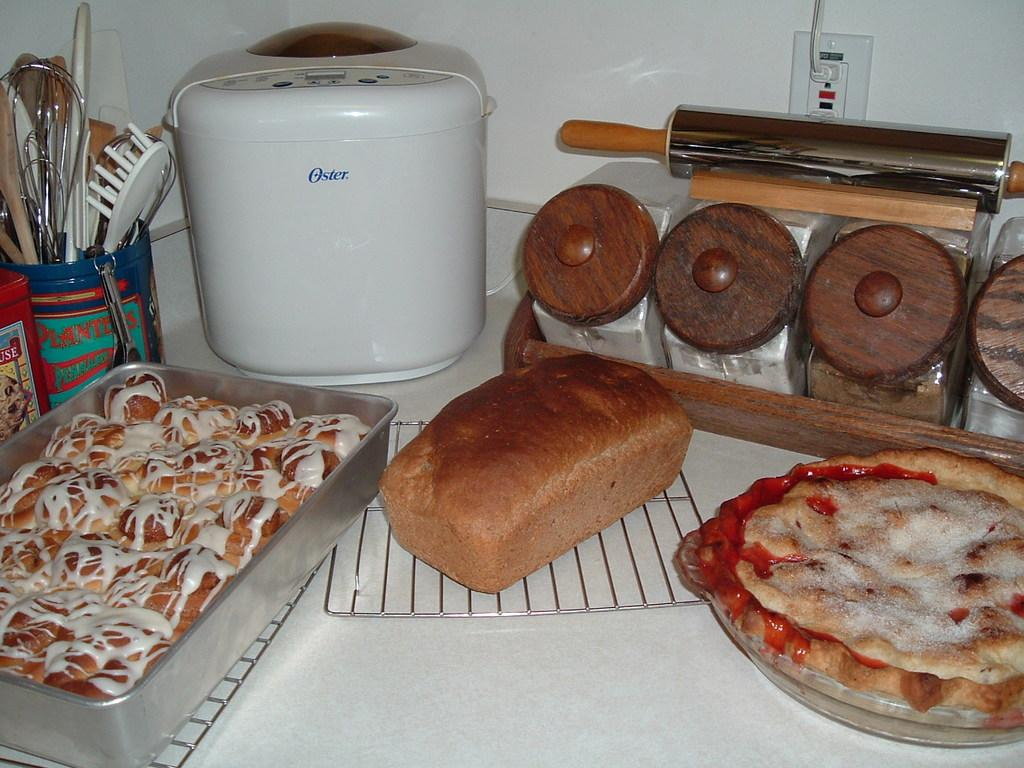<image>
Share a concise interpretation of the image provided. An Oster appliance can be seen next to an assortment of baked goods. 